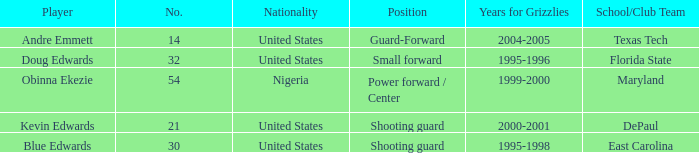When did no. 32 play for grizzles 1995-1996. 